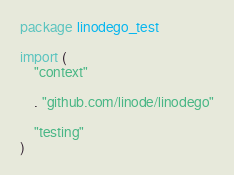<code> <loc_0><loc_0><loc_500><loc_500><_Go_>package linodego_test

import (
	"context"

	. "github.com/linode/linodego"

	"testing"
)
</code> 